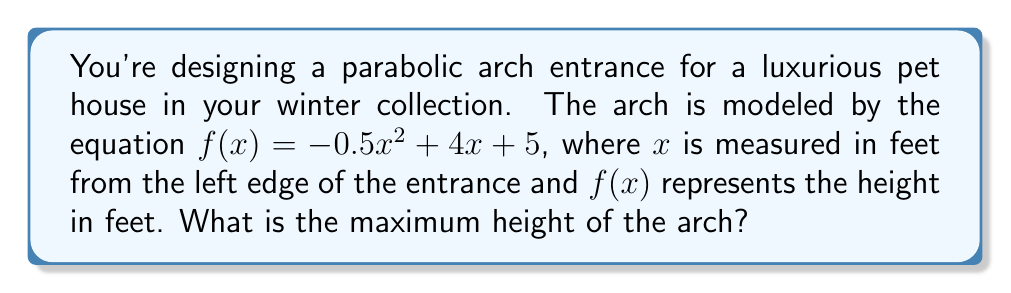Teach me how to tackle this problem. To find the maximum height of the parabolic arch, we need to follow these steps:

1) The equation of the arch is in the form of a quadratic function:
   $f(x) = -0.5x^2 + 4x + 5$

2) For a quadratic function $f(x) = ax^2 + bx + c$, the x-coordinate of the vertex is given by $x = -\frac{b}{2a}$

3) In our case, $a = -0.5$ and $b = 4$. Let's calculate the x-coordinate of the vertex:

   $x = -\frac{4}{2(-0.5)} = -\frac{4}{-1} = 4$

4) To find the maximum height, we need to calculate $f(4)$:

   $f(4) = -0.5(4)^2 + 4(4) + 5$
   $= -0.5(16) + 16 + 5$
   $= -8 + 16 + 5$
   $= 13$

5) Therefore, the maximum height of the arch occurs at $x = 4$ feet from the left edge, and the height at this point is 13 feet.
Answer: 13 feet 